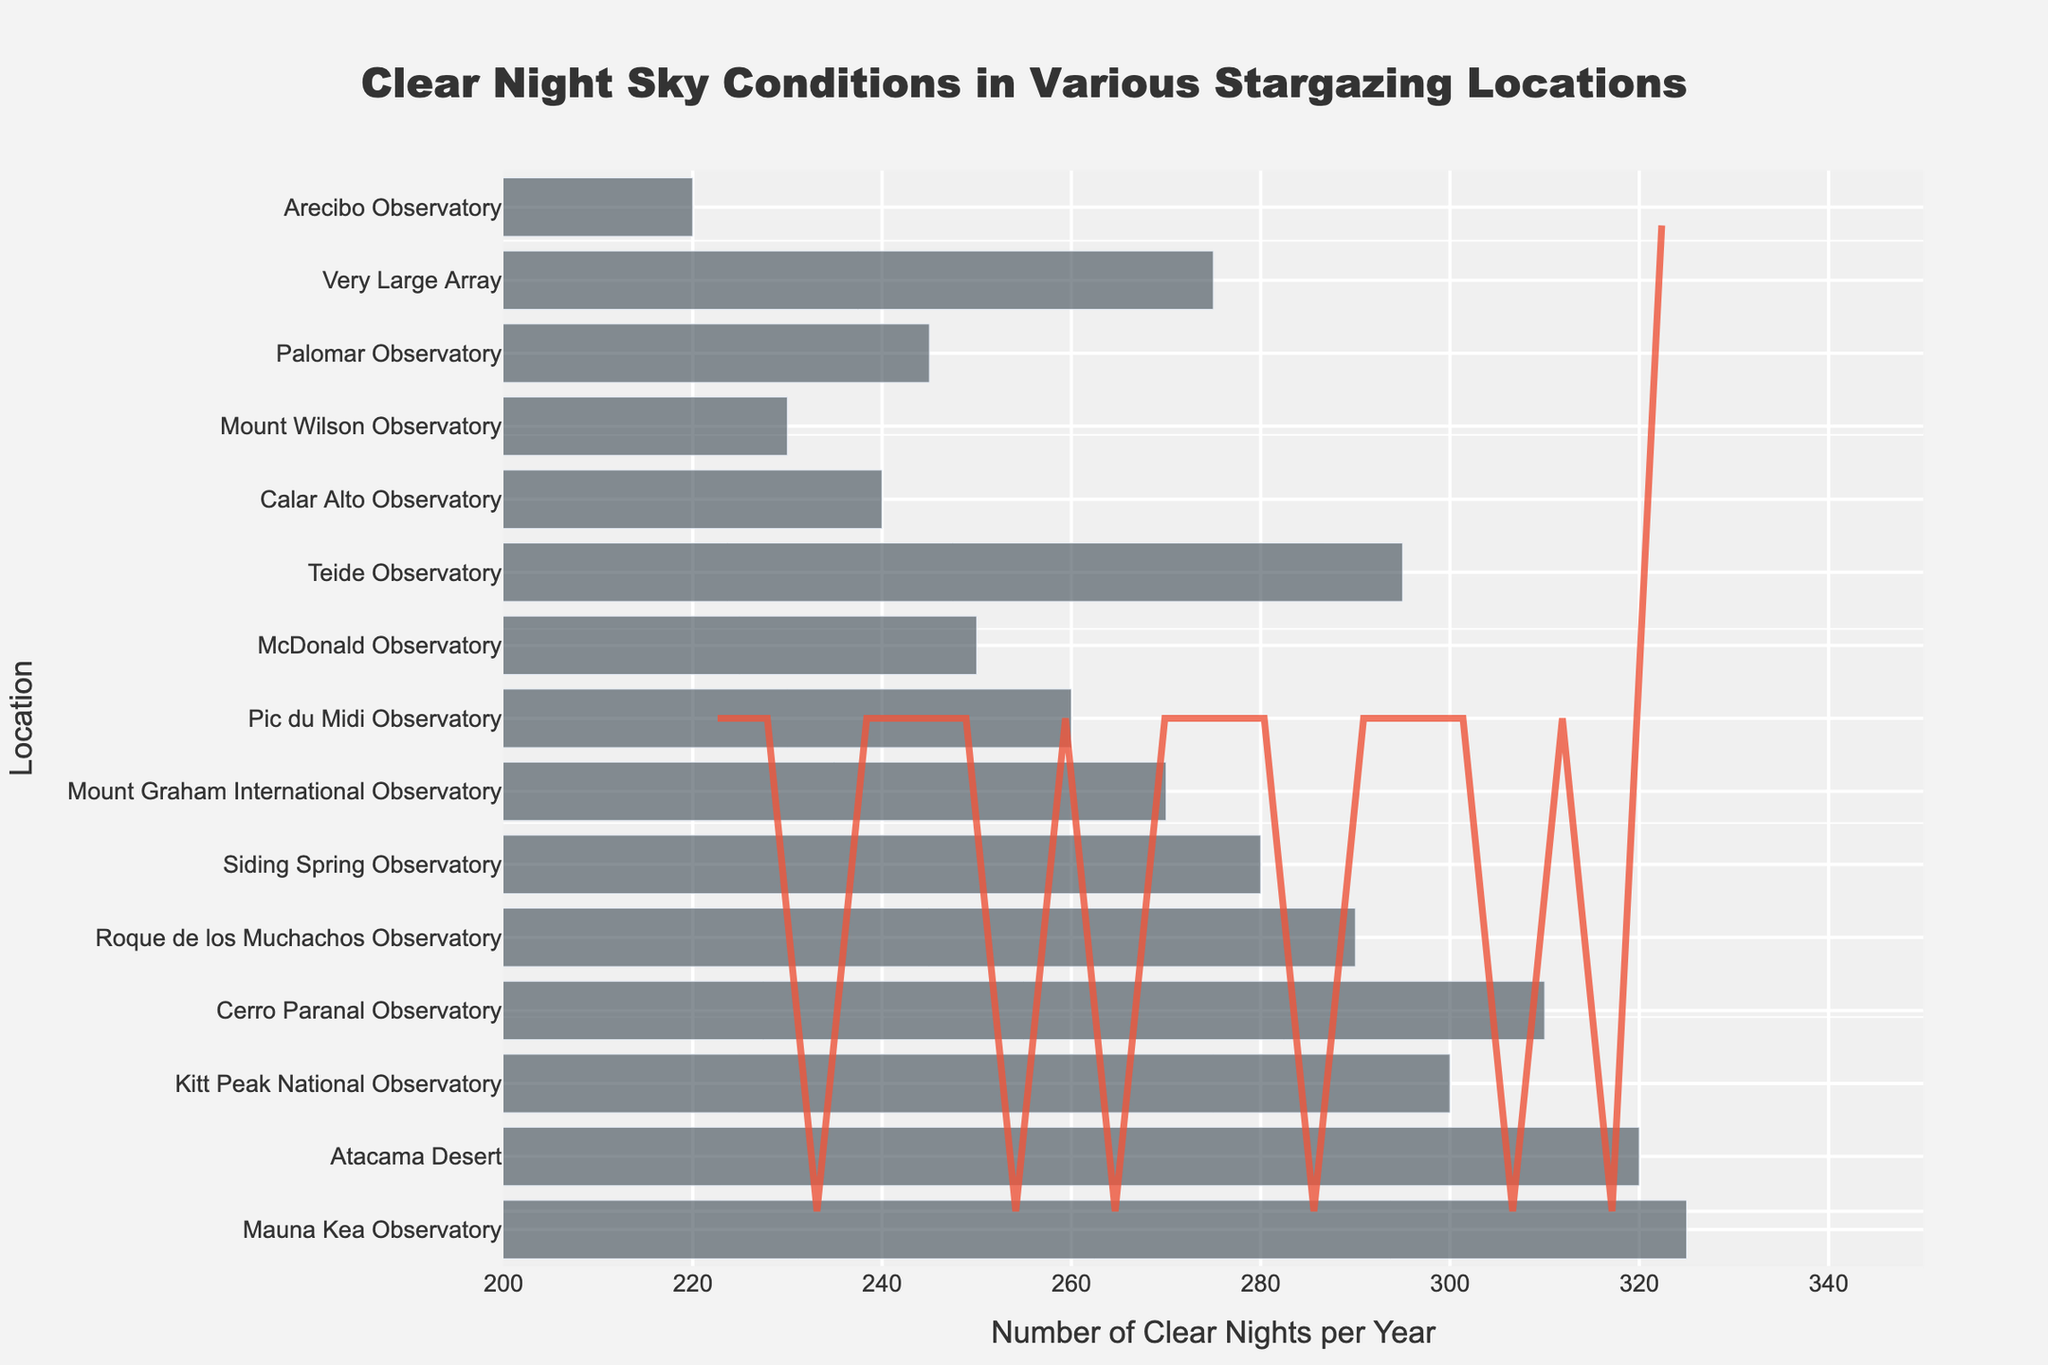How many locations are listed in the chart? Count the number of unique locations labeled on the y-axis.
Answer: 15 What is the highest number of clear nights per year observed in a location? Identify the location with the highest bar on the x-axis and read the value.
Answer: 325 Which location has the most clear nights per year? Find the bar corresponding to the highest value on the x-axis and reference its associated location on the y-axis.
Answer: Mauna Kea Observatory How many locations have more than 300 clear nights per year? Count the number of bars on the x-axis that exceed the 300 mark.
Answer: 4 What's the average number of clear nights per year across all listed locations? Sum the clear nights per year for all locations and divide by the number of locations (3270 / 15).
Answer: 218 Which location has the least number of clear nights per year? Identify the location with the shortest bar on the x-axis and read the location.
Answer: Arecibo Observatory What's the range of clear nights per year among the stargazing locations? Subtract the smallest value from the largest value among the clear nights per year (325 - 220).
Answer: 105 How does the density curve indicate the distribution of clear nights per year? Observe the KDE curve to determine if the data is skewed left or right, and see how the values cluster.
Answer: The KDE shows a right-skewed distribution around 250-300 Which locations have between 240 and 260 clear nights per year? Identify the bars on the x-axis that fall within this range and reference their associated locations on the y-axis.
Answer: Pic du Midi Observatory (260), Calar Alto Observatory (240) What is the median number of clear nights per year across the listed locations? Arrange the data points in ascending order and find the middle value (or the average of the two middle values if the number is even). The median is calculated as 270.
Answer: 270 